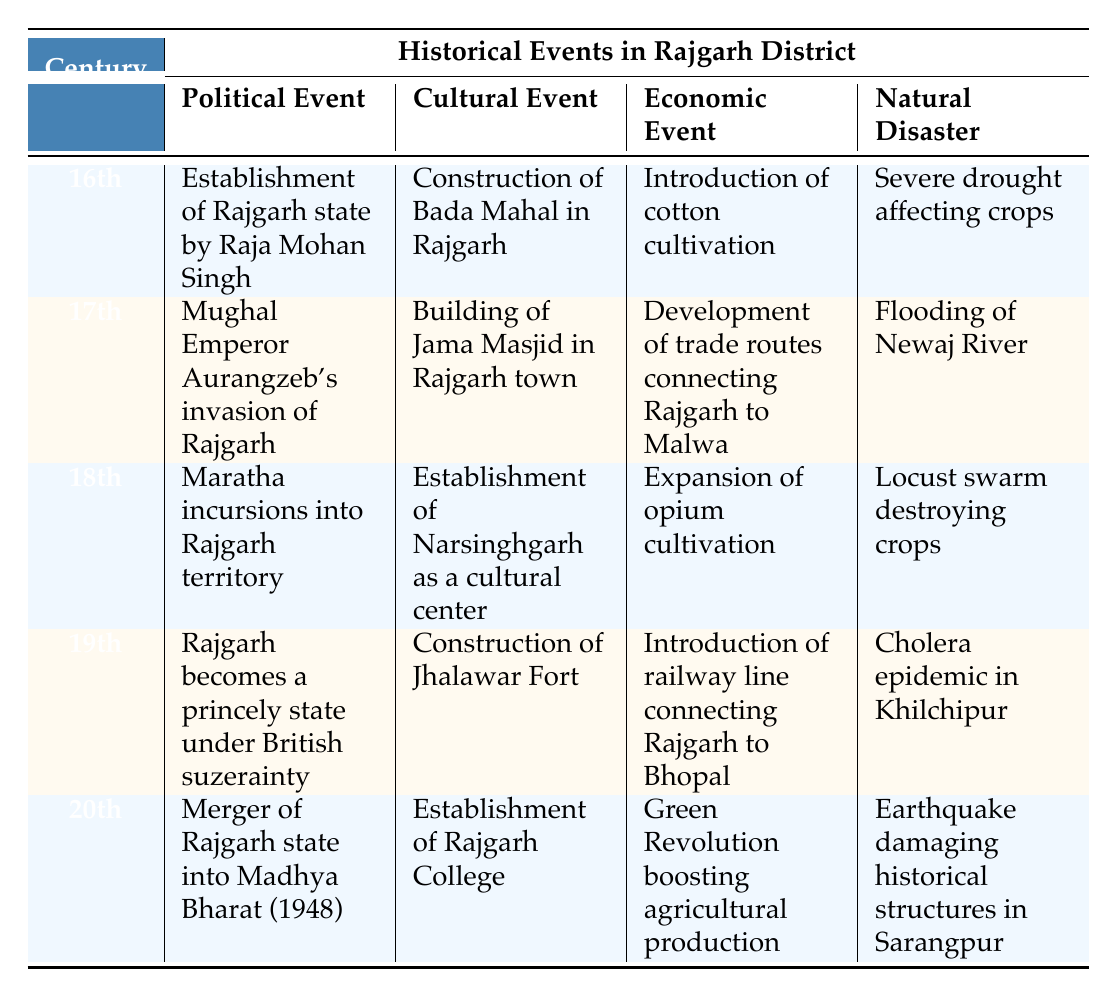What significant cultural event occurred in the 16th century in Rajgarh district? The table shows that the significant cultural event in the 16th century was the construction of Bada Mahal in Rajgarh.
Answer: Construction of Bada Mahal in Rajgarh What natural disaster affected the crops in the 18th century? According to the table, the natural disaster in the 18th century was a locust swarm that destroyed crops.
Answer: Locust swarm destroying crops Which century saw Rajgarh become a princely state under British suzerainty? The data indicates that the 19th century was when Rajgarh became a princely state under British suzerainty.
Answer: 19th century Were there any cultural events listed for the 20th century? Yes, the table lists the establishment of Rajgarh College as a cultural event in the 20th century.
Answer: Yes Compare the economic events in the 17th and 19th centuries in Rajgarh district. In the 17th century, the economic event was the development of trade routes connecting Rajgarh to Malwa, while in the 19th century, it was the introduction of a railway line connecting Rajgarh to Bhopal. Thus, one focuses on trade routes and the other on transportation infrastructure.
Answer: Development of trade routes; Introduction of railway line What was the political event during the 20th century in Rajgarh? The political event recorded for the 20th century is the merger of Rajgarh state into Madhya Bharat in 1948, as per the table.
Answer: Merger of Rajgarh state into Madhya Bharat (1948) Which century had the most natural disasters mentioned in the table? By analyzing the table, the 19th century had a cholera epidemic listed along with natural events, but each other century only mentions one natural disaster. Thus, it suggests that multiple events in the 19th century could indicate a higher incidence of natural challenges.
Answer: 19th century What political event took place in the 17th century? The political event listed for the 17th century is Mughal Emperor Aurangzeb's invasion of Rajgarh.
Answer: Mughal Emperor Aurangzeb's invasion of Rajgarh If you had to list the natural disasters chronologically from the 16th to the 20th century, which ones would you mention? The chronological order based on the table would be severe drought in the 16th century, flooding in the 17th century, locust swarm in the 18th century, cholera epidemic in the 19th century, and an earthquake in the 20th century.
Answer: Severe drought; Flooding; Locust swarm; Cholera epidemic; Earthquake 